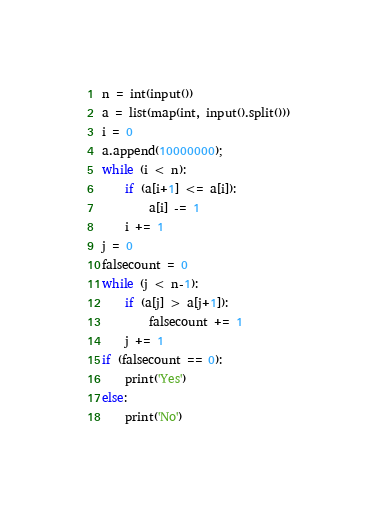Convert code to text. <code><loc_0><loc_0><loc_500><loc_500><_Python_>n = int(input())
a = list(map(int, input().split()))
i = 0
a.append(10000000);
while (i < n):
    if (a[i+1] <= a[i]):
        a[i] -= 1
    i += 1
j = 0
falsecount = 0
while (j < n-1):
    if (a[j] > a[j+1]):
        falsecount += 1
    j += 1
if (falsecount == 0):
    print('Yes')
else:
    print('No')</code> 